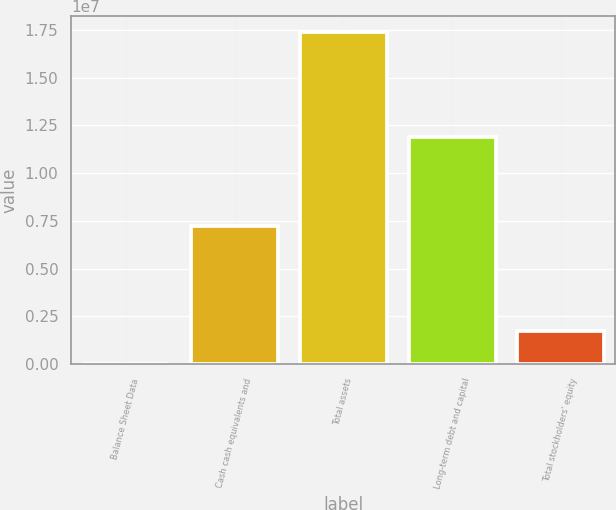Convert chart to OTSL. <chart><loc_0><loc_0><loc_500><loc_500><bar_chart><fcel>Balance Sheet Data<fcel>Cash cash equivalents and<fcel>Total assets<fcel>Long-term debt and capital<fcel>Total stockholders' equity<nl><fcel>2012<fcel>7.20538e+06<fcel>1.73796e+07<fcel>1.18877e+07<fcel>1.73977e+06<nl></chart> 